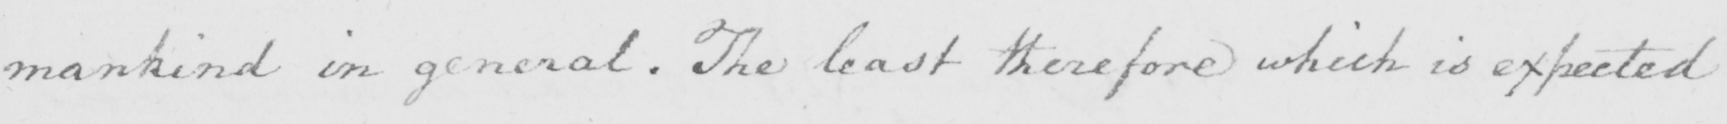Can you tell me what this handwritten text says? mankind in general . The least therefore which is expected 